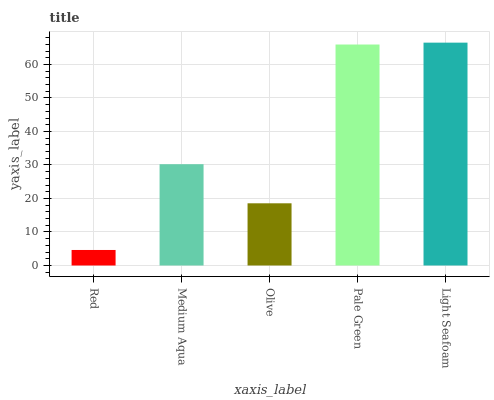Is Red the minimum?
Answer yes or no. Yes. Is Light Seafoam the maximum?
Answer yes or no. Yes. Is Medium Aqua the minimum?
Answer yes or no. No. Is Medium Aqua the maximum?
Answer yes or no. No. Is Medium Aqua greater than Red?
Answer yes or no. Yes. Is Red less than Medium Aqua?
Answer yes or no. Yes. Is Red greater than Medium Aqua?
Answer yes or no. No. Is Medium Aqua less than Red?
Answer yes or no. No. Is Medium Aqua the high median?
Answer yes or no. Yes. Is Medium Aqua the low median?
Answer yes or no. Yes. Is Red the high median?
Answer yes or no. No. Is Pale Green the low median?
Answer yes or no. No. 